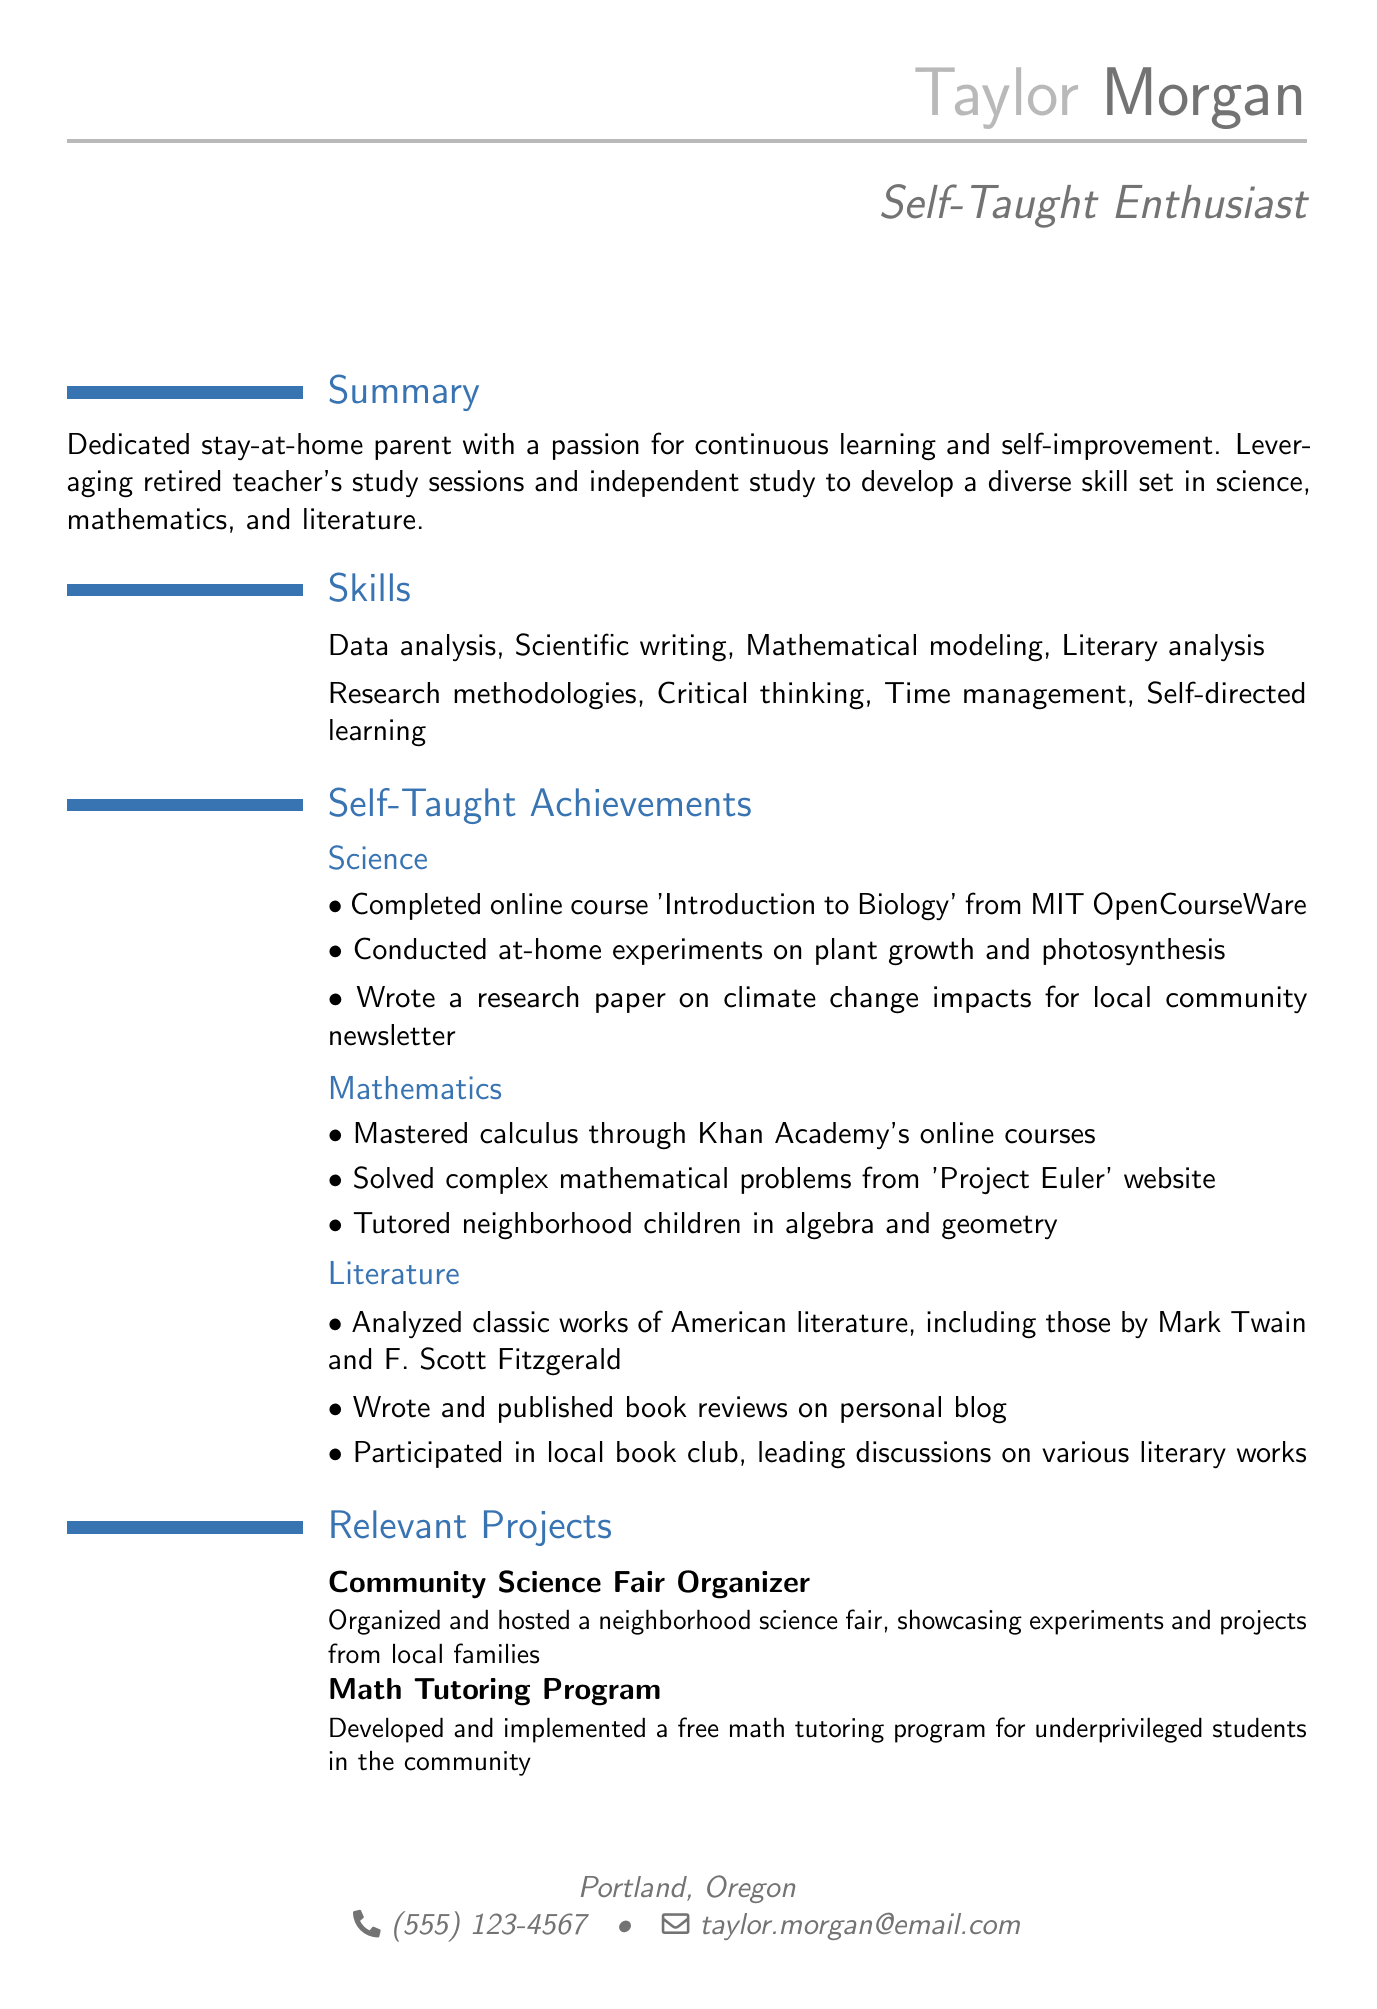What is the name of the individual? The name of the individual is listed in the personal information section of the document.
Answer: Taylor Morgan What year did Taylor graduate? The graduation year is mentioned under the education section, specifying when the degree was received.
Answer: 2010 Which online course in biology did Taylor complete? The specific course name is provided in the self-taught achievements under the science section.
Answer: Introduction to Biology How many areas of self-taught achievements are listed? The document contains a section that outlines different areas of self-taught achievements.
Answer: Three What type of certificate did Taylor earn related to data analytics? The certifications section provides specific details on the types of certifications earned.
Answer: Google Data Analytics Professional Certificate What is a relevant project related to math mentioned? The relevant projects section describes projects that demonstrate Taylor's engagement in community efforts, specifically mentioning math.
Answer: Math Tutoring Program In which city does Taylor reside? The location is directly mentioned in the personal information section.
Answer: Portland, Oregon Who does Taylor leverage for study sessions? The summary section describes whom Taylor collaborates with for study enhancement.
Answer: Retired teacher 